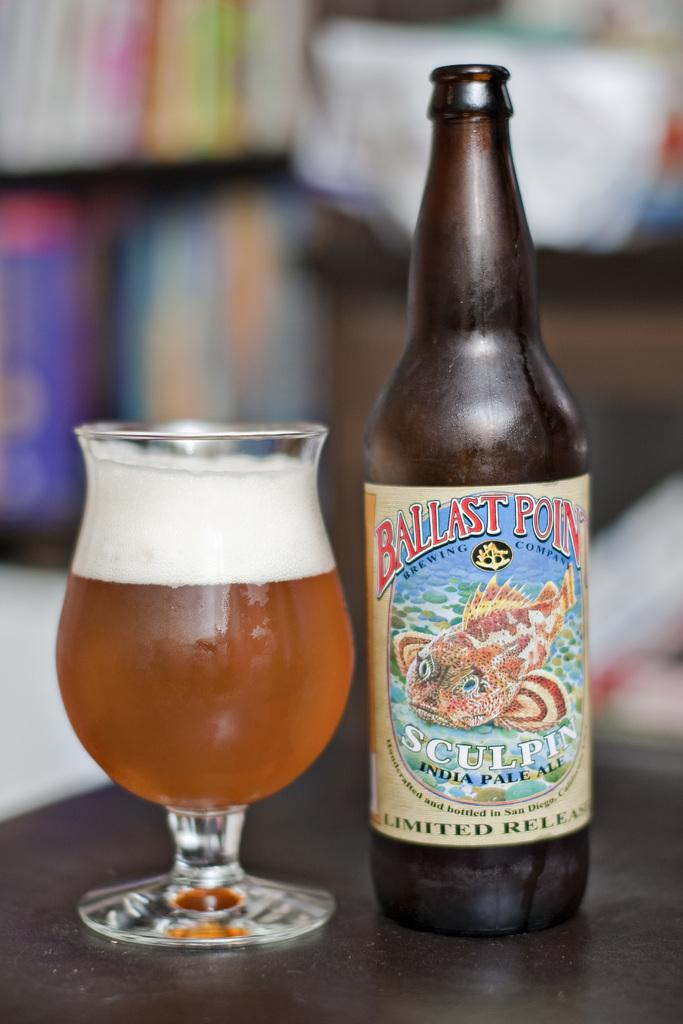<image>
Create a compact narrative representing the image presented. A limited release of Ballast Point beer is on the table. 